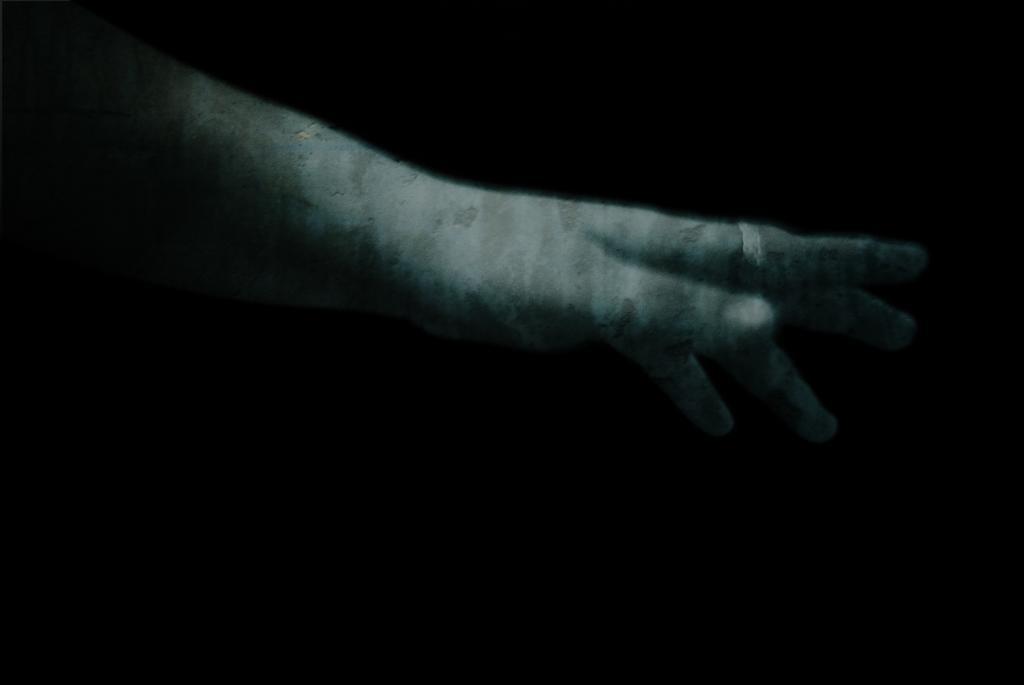In one or two sentences, can you explain what this image depicts? In this picture we can observe a human hand. There is a ring to the finger. In the background it is completely dark. 